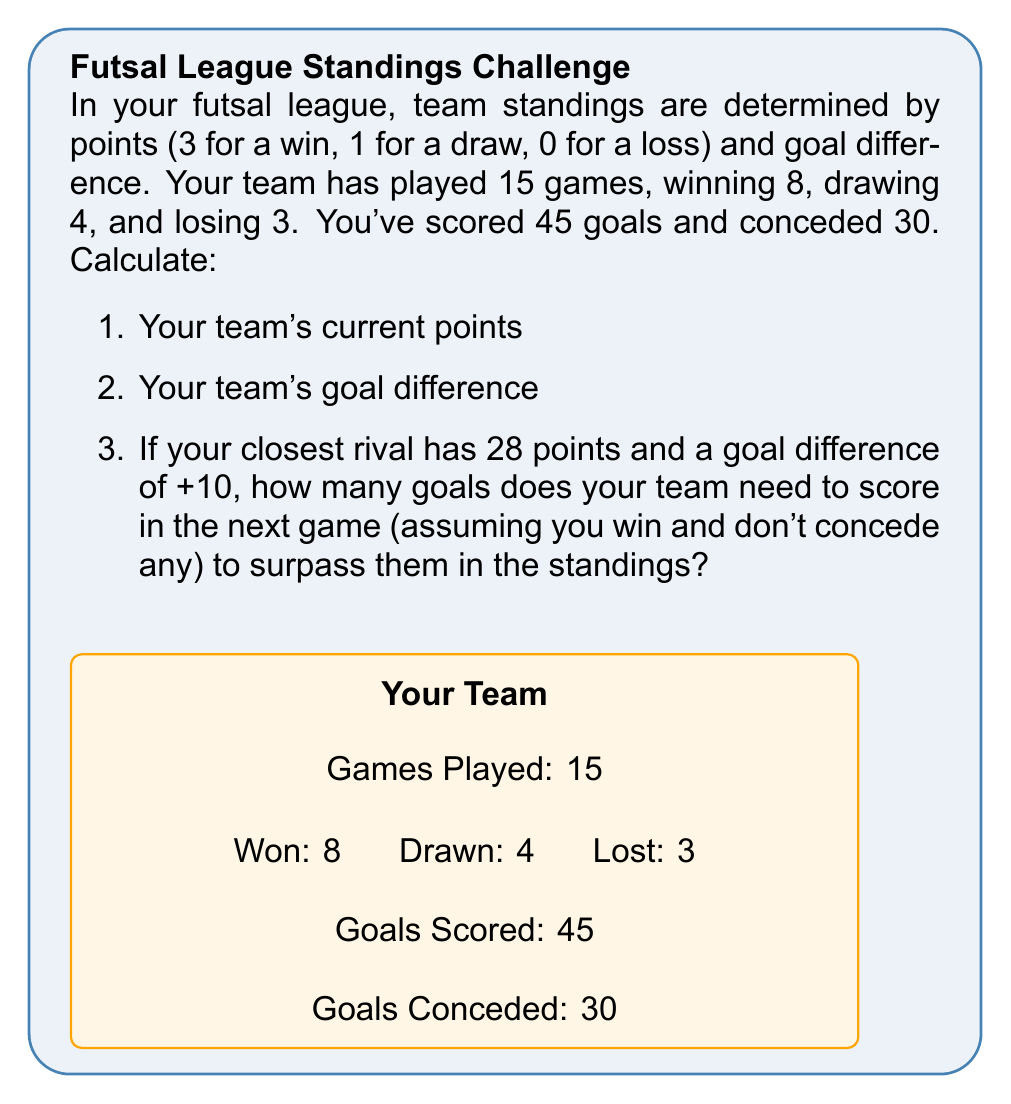Can you solve this math problem? Let's solve this step-by-step:

1) Calculating your team's current points:
   - Wins: 8 × 3 = 24 points
   - Draws: 4 × 1 = 4 points
   - Losses: 3 × 0 = 0 points
   Total points = $24 + 4 + 0 = 28$ points

2) Calculating your team's goal difference:
   Goal Difference = Goals Scored - Goals Conceded
   $$ GD = 45 - 30 = +15 $$

3) To surpass the rival team:
   - You need more points OR equal points and better goal difference
   - You already have equal points (28)
   - You need to improve your goal difference to be better than +10
   - Current goal difference gap: $15 - 10 = 5$
   - To surpass, you need to score at least 6 goals in the next game

   Let $x$ be the number of goals you need to score:
   $$ (45 + x) - 30 > 10 $$
   $$ x > 10 - 15 $$
   $$ x > -5 $$

   Since $x$ must be a positive integer, the minimum value for $x$ is 1.
   However, to actually surpass the rival team, you need:
   $$ x \geq 6 $$

Therefore, you need to score at least 6 goals in the next game to surpass your rival in the standings.
Answer: 1) 28 points
2) +15
3) 6 goals 